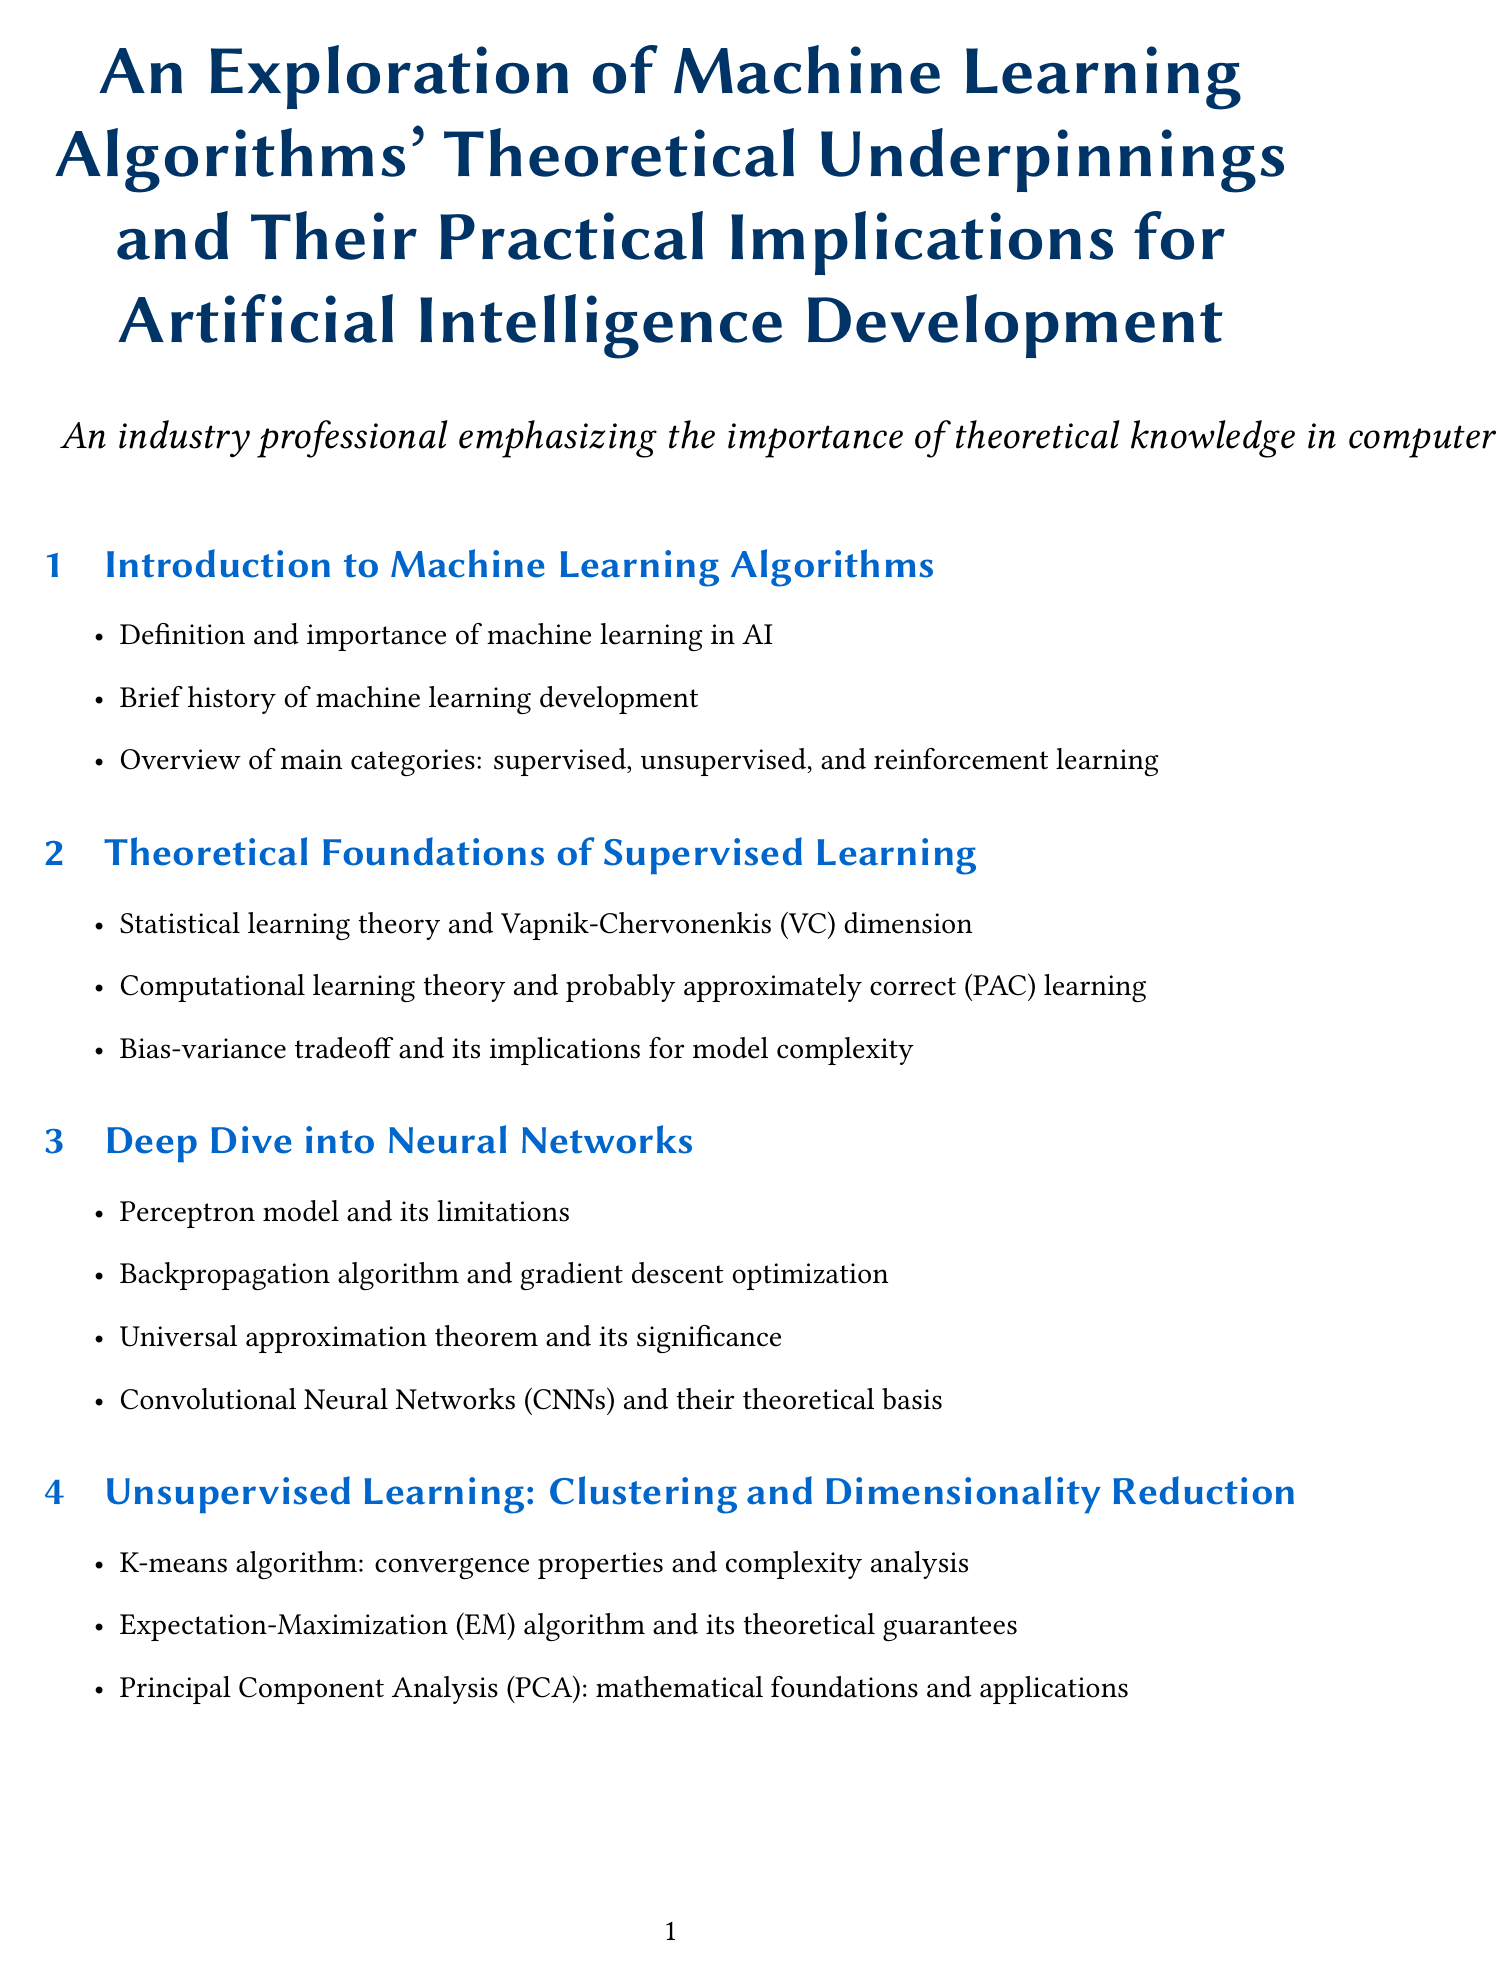What are the main categories of machine learning? The document lists the main categories of machine learning as supervised, unsupervised, and reinforcement learning.
Answer: supervised, unsupervised, reinforcement learning Who authored "Pattern Recognition and Machine Learning"? The key reference section identifies Christopher M. Bishop as the author of this work.
Answer: Christopher M. Bishop What does the VC in VC dimension stand for? The section on theoretical foundations mentions the Vapnik-Chervonenkis dimension, indicating that VC stands for Vapnik-Chervonenkis.
Answer: Vapnik-Chervonenkis What is AdaBoost known for? The ensemble methods section states that the AdaBoost algorithm is known for its convergence properties.
Answer: convergence properties What theorem relates to the ability of neural networks to approximate functions? The universal approximation theorem is highlighted for its significance in relating to neural networks' function approximation ability.
Answer: universal approximation theorem Which year was "Reinforcement Learning: An Introduction" published? The key references section lists 2018 as the publication year for "Reinforcement Learning: An Introduction".
Answer: 2018 What is the theoretical focus of K-means algorithm? The unsupervised learning section discusses the convergence properties and complexity analysis as the theoretical focus of the K-means algorithm.
Answer: convergence properties and complexity analysis What type of learning method is Q-learning classified under? The report categorizes Q-learning as part of reinforcement learning fundamentals.
Answer: reinforcement learning What is a key ethical consideration discussed in the report? The report mentions bias and fairness issues arising from algorithmic assumptions as a key ethical consideration.
Answer: bias and fairness issues 